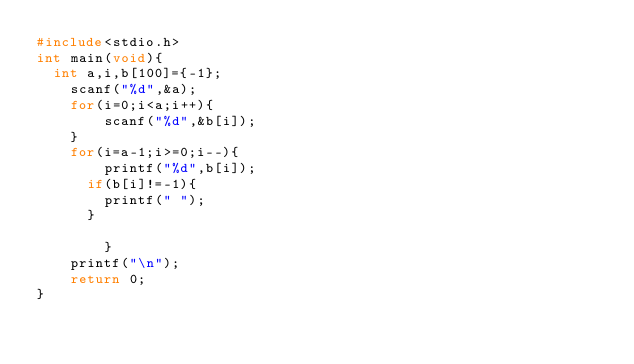<code> <loc_0><loc_0><loc_500><loc_500><_C_>#include<stdio.h>
int main(void){
	int a,i,b[100]={-1};
    scanf("%d",&a);
    for(i=0;i<a;i++){
        scanf("%d",&b[i]);
    }
    for(i=a-1;i>=0;i--){
        printf("%d",b[i]);
    	if(b[i]!=-1){
    		printf(" ");
    	}
        
        }
    printf("\n");
    return 0;
}</code> 